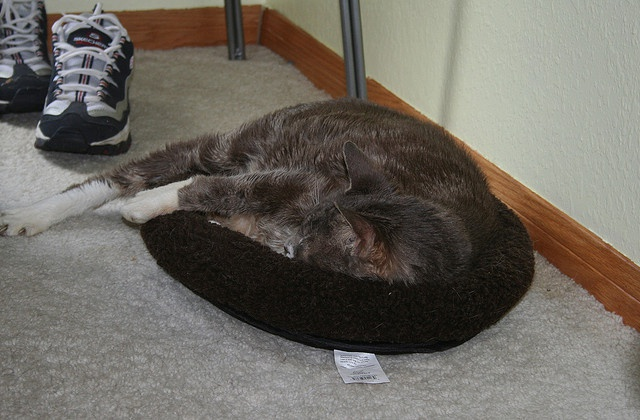Describe the objects in this image and their specific colors. I can see a cat in gray, black, and darkgray tones in this image. 